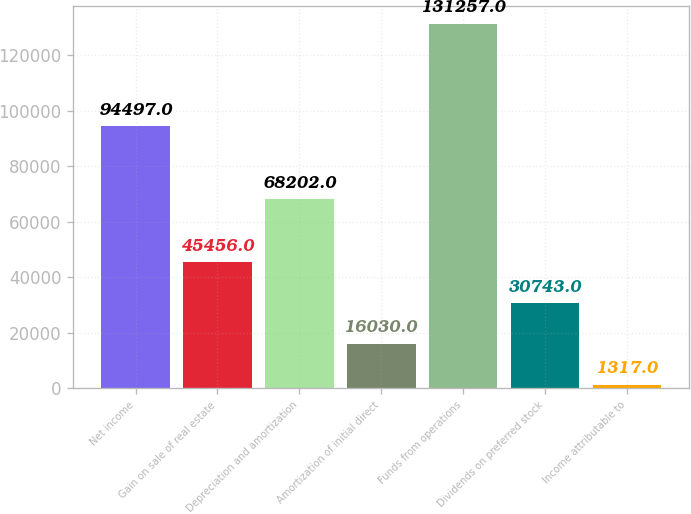Convert chart. <chart><loc_0><loc_0><loc_500><loc_500><bar_chart><fcel>Net income<fcel>Gain on sale of real estate<fcel>Depreciation and amortization<fcel>Amortization of initial direct<fcel>Funds from operations<fcel>Dividends on preferred stock<fcel>Income attributable to<nl><fcel>94497<fcel>45456<fcel>68202<fcel>16030<fcel>131257<fcel>30743<fcel>1317<nl></chart> 